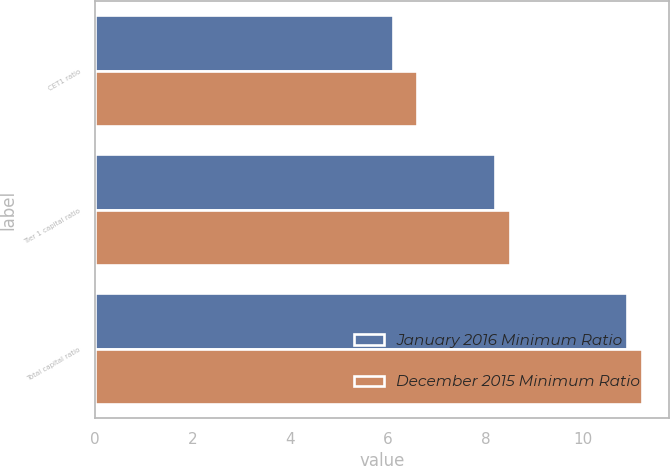Convert chart to OTSL. <chart><loc_0><loc_0><loc_500><loc_500><stacked_bar_chart><ecel><fcel>CET1 ratio<fcel>Tier 1 capital ratio<fcel>Total capital ratio<nl><fcel>January 2016 Minimum Ratio<fcel>6.1<fcel>8.2<fcel>10.9<nl><fcel>December 2015 Minimum Ratio<fcel>6.6<fcel>8.5<fcel>11.2<nl></chart> 